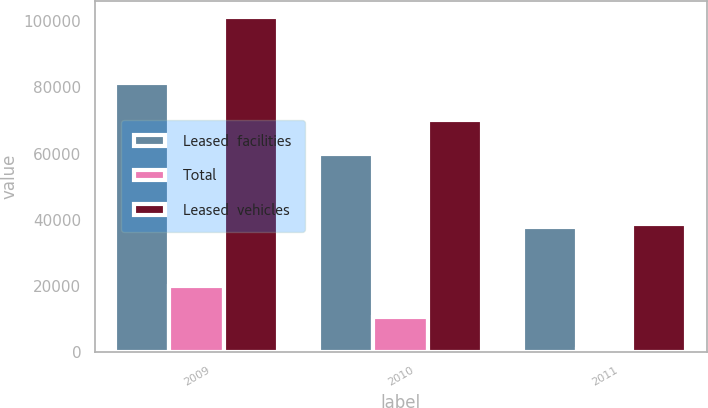<chart> <loc_0><loc_0><loc_500><loc_500><stacked_bar_chart><ecel><fcel>2009<fcel>2010<fcel>2011<nl><fcel>Leased  facilities<fcel>81267<fcel>59821<fcel>37723<nl><fcel>Total<fcel>19913<fcel>10477<fcel>1042<nl><fcel>Leased  vehicles<fcel>101180<fcel>70298<fcel>38765<nl></chart> 